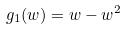<formula> <loc_0><loc_0><loc_500><loc_500>g _ { 1 } ( w ) = w - w ^ { 2 }</formula> 